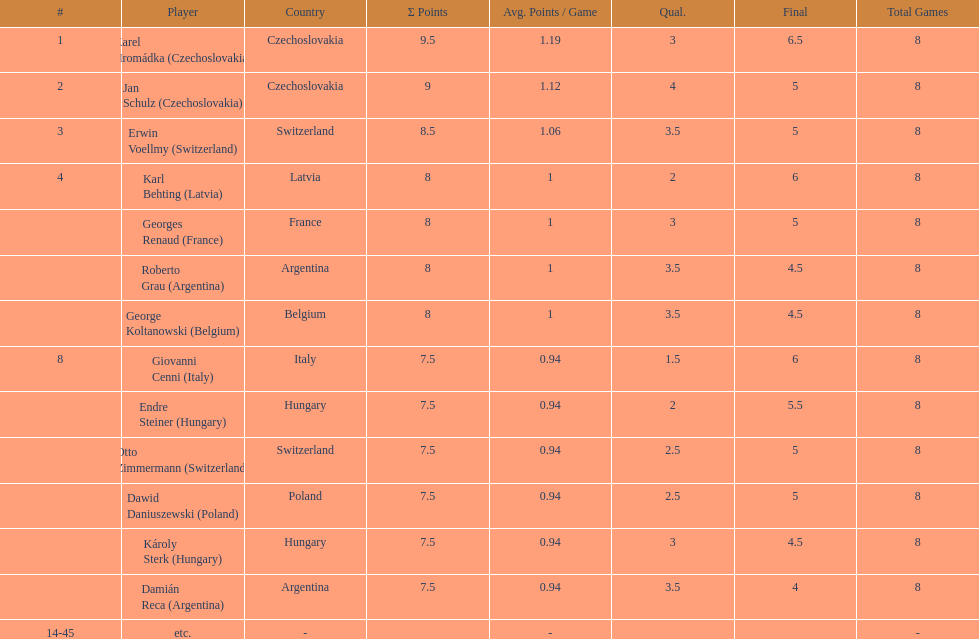Did the hungarian duo score higher or lower combined points than the argentine pair? Less. 